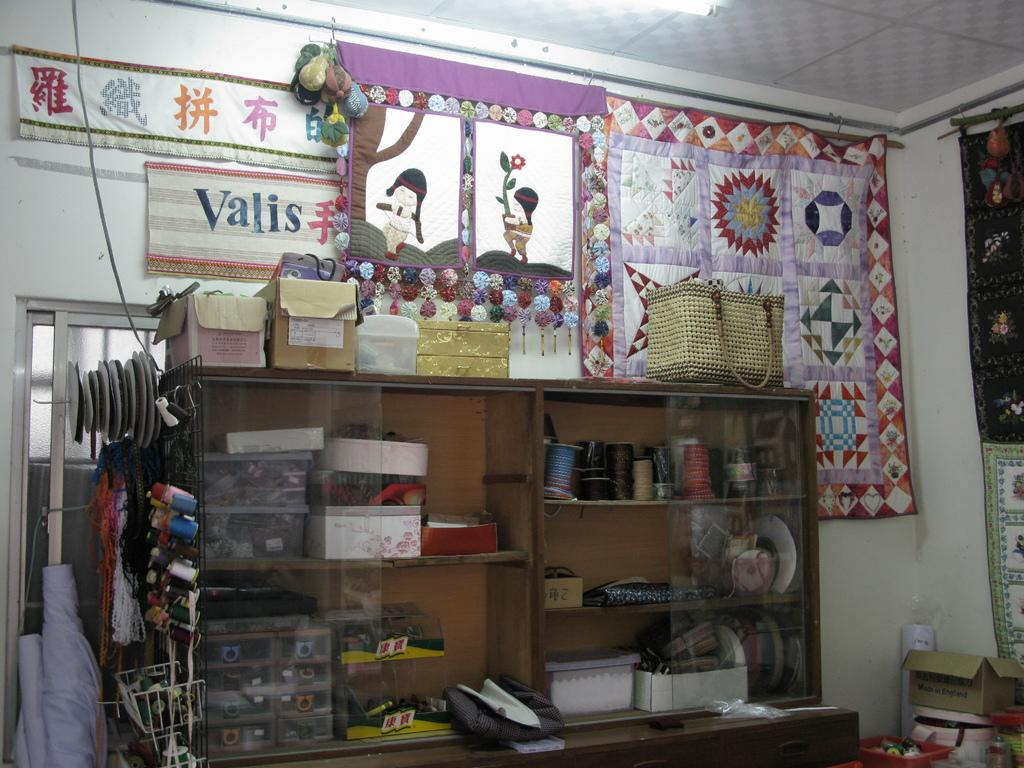<image>
Give a short and clear explanation of the subsequent image. The interior of a sewing shop has a sign that says Valis. 